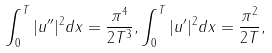Convert formula to latex. <formula><loc_0><loc_0><loc_500><loc_500>\int _ { 0 } ^ { T } | u ^ { \prime \prime } | ^ { 2 } d x = \frac { \pi ^ { 4 } } { 2 T ^ { 3 } } , \int _ { 0 } ^ { T } | u ^ { \prime } | ^ { 2 } d x = \frac { \pi ^ { 2 } } { 2 T } ,</formula> 